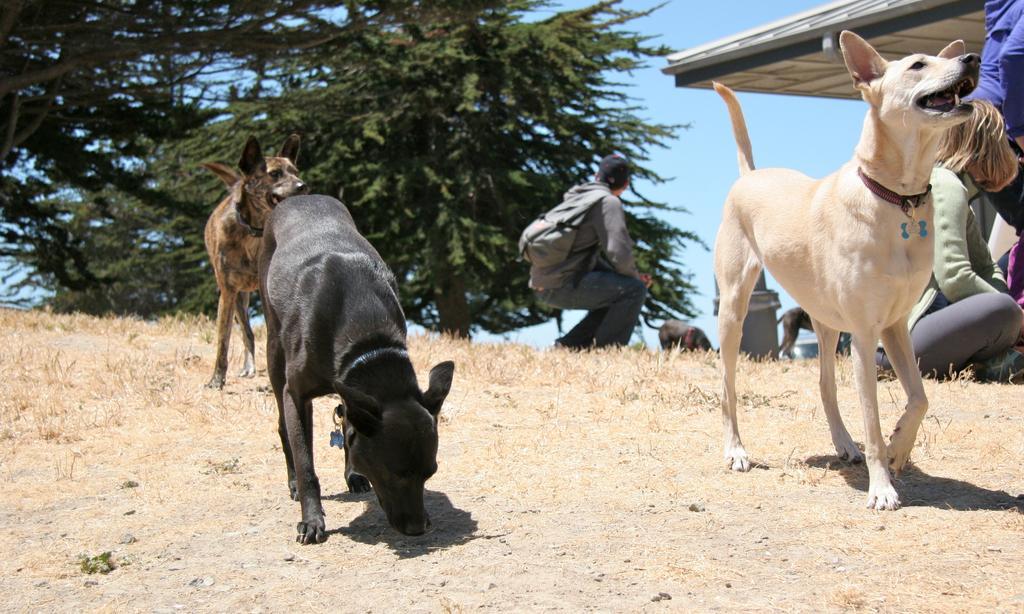Can you describe this image briefly? As we can see in the image there are dogs, few people here and there, trees and sky. 